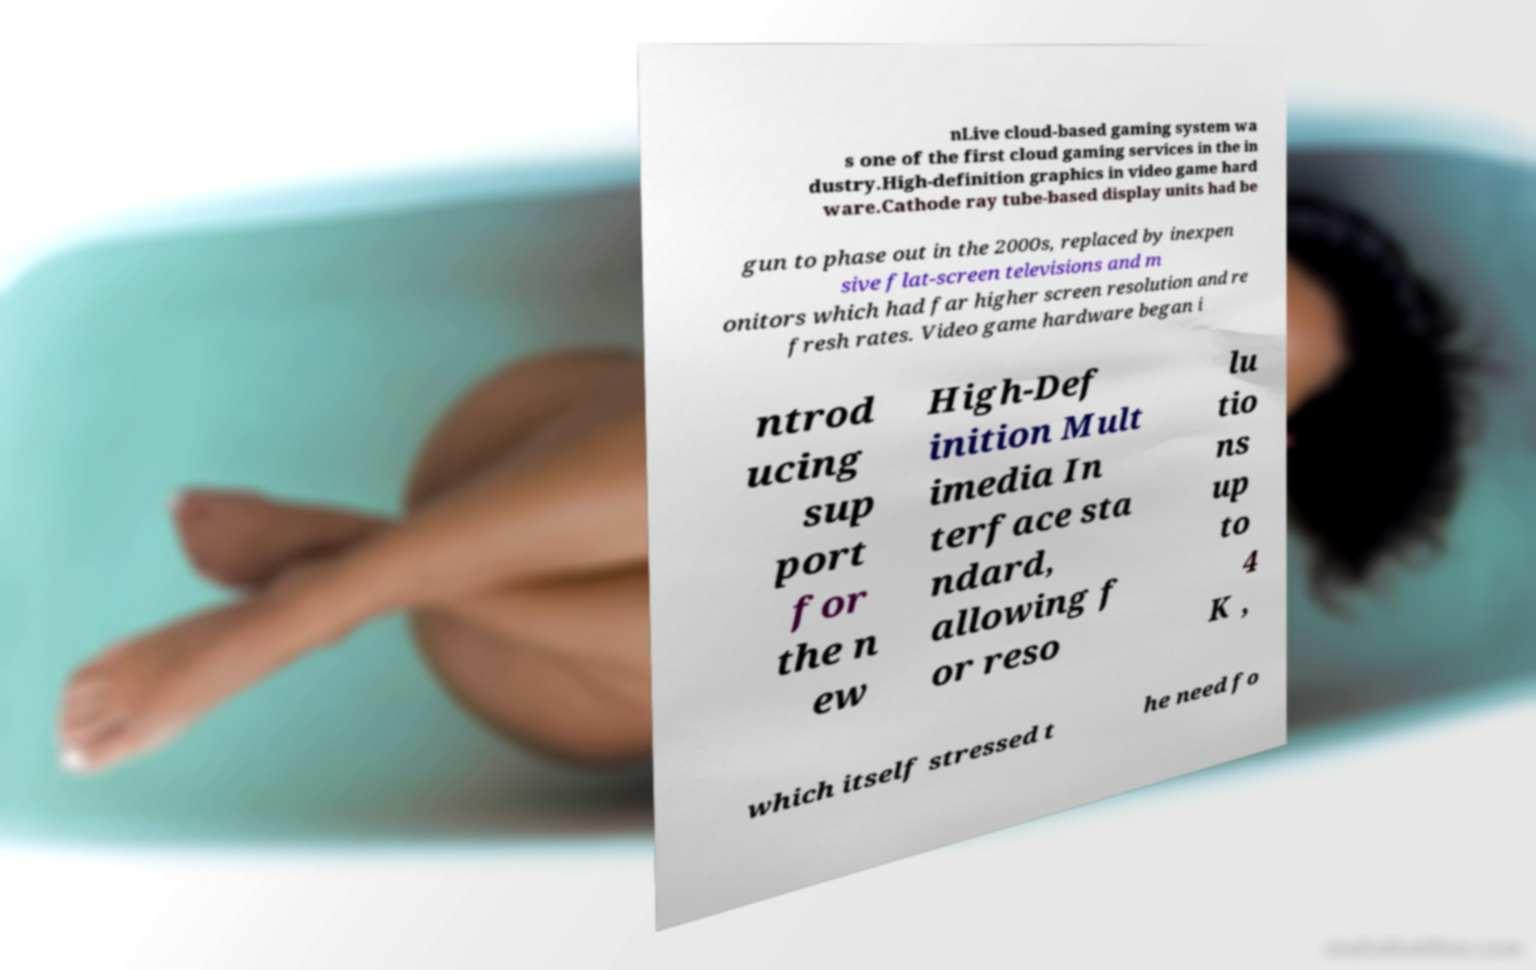Please identify and transcribe the text found in this image. nLive cloud-based gaming system wa s one of the first cloud gaming services in the in dustry.High-definition graphics in video game hard ware.Cathode ray tube-based display units had be gun to phase out in the 2000s, replaced by inexpen sive flat-screen televisions and m onitors which had far higher screen resolution and re fresh rates. Video game hardware began i ntrod ucing sup port for the n ew High-Def inition Mult imedia In terface sta ndard, allowing f or reso lu tio ns up to 4 K , which itself stressed t he need fo 